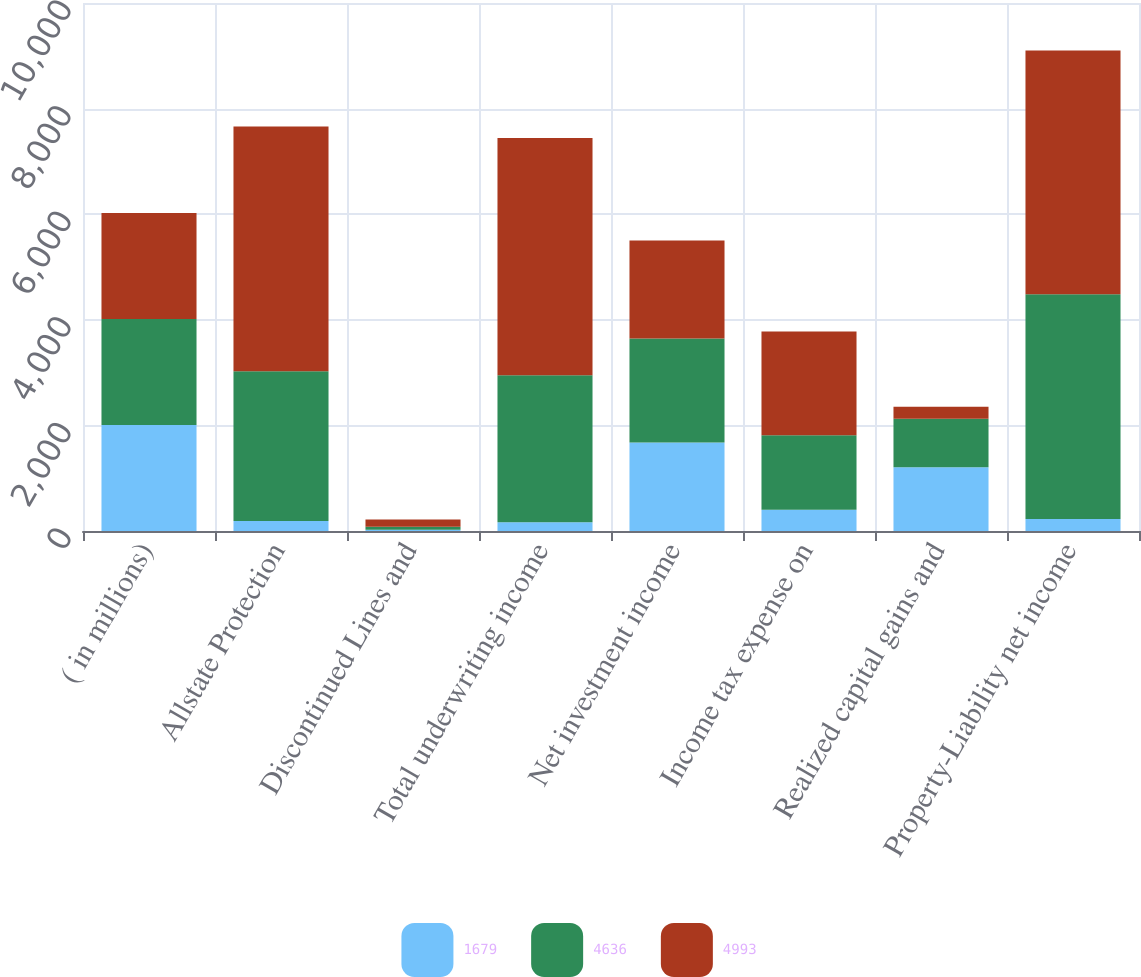<chart> <loc_0><loc_0><loc_500><loc_500><stacked_bar_chart><ecel><fcel>( in millions)<fcel>Allstate Protection<fcel>Discontinued Lines and<fcel>Total underwriting income<fcel>Net investment income<fcel>Income tax expense on<fcel>Realized capital gains and<fcel>Property-Liability net income<nl><fcel>1679<fcel>2008<fcel>189<fcel>25<fcel>164<fcel>1674<fcel>401<fcel>1209<fcel>228<nl><fcel>4636<fcel>2007<fcel>2838<fcel>54<fcel>2784<fcel>1972<fcel>1413<fcel>915<fcel>4258<nl><fcel>4993<fcel>2006<fcel>4636<fcel>139<fcel>4497<fcel>1854<fcel>1963<fcel>227<fcel>4614<nl></chart> 